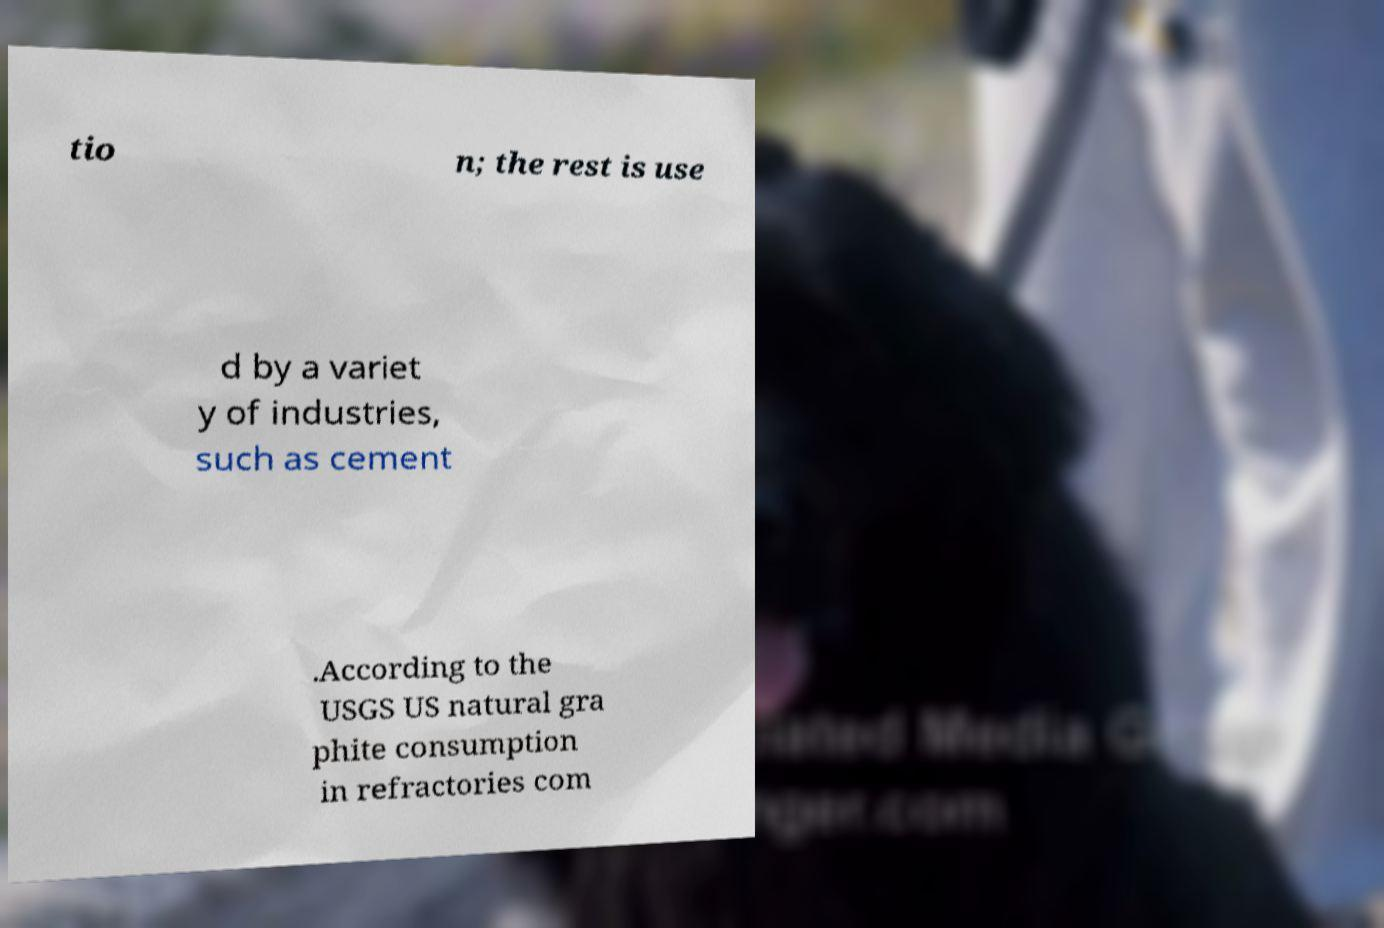Could you assist in decoding the text presented in this image and type it out clearly? tio n; the rest is use d by a variet y of industries, such as cement .According to the USGS US natural gra phite consumption in refractories com 